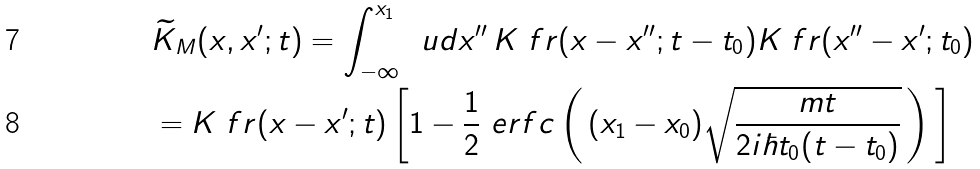<formula> <loc_0><loc_0><loc_500><loc_500>& \widetilde { K } _ { M } ( x , x ^ { \prime } ; t ) = \int _ { - \infty } ^ { x _ { 1 } } \, \ u d x ^ { \prime \prime } \, K _ { \ } f r ( x - x ^ { \prime \prime } ; t - t _ { 0 } ) K _ { \ } f r ( x ^ { \prime \prime } - x ^ { \prime } ; t _ { 0 } ) \\ & = K _ { \ } f r ( x - x ^ { \prime } ; t ) \left [ 1 - \frac { 1 } { 2 } \ e r f c \left ( \, ( x _ { 1 } - x _ { 0 } ) \sqrt { \frac { m t } { 2 i \hbar { t } _ { 0 } ( t - t _ { 0 } ) } } \, \right ) \, \right ]</formula> 